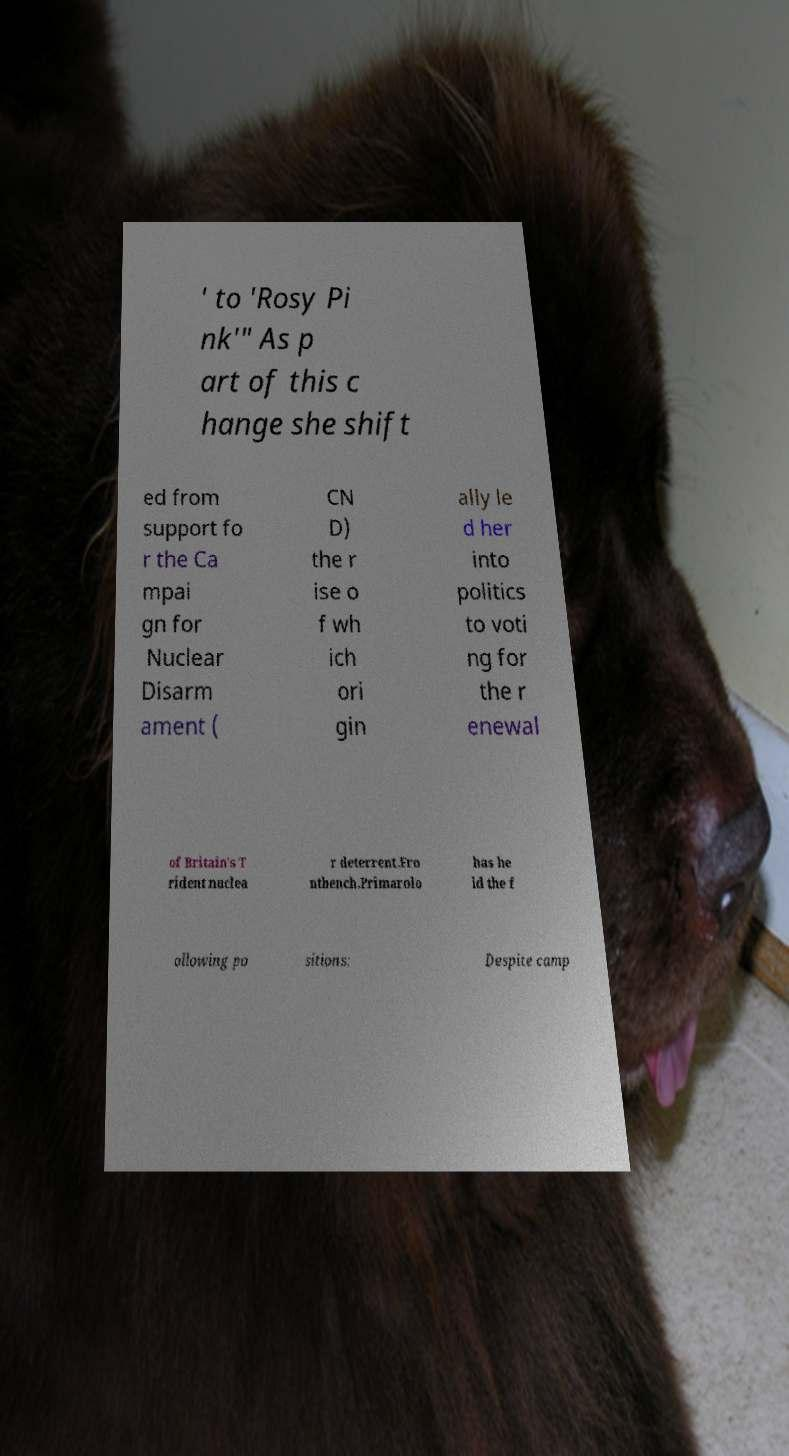Can you accurately transcribe the text from the provided image for me? ' to 'Rosy Pi nk'" As p art of this c hange she shift ed from support fo r the Ca mpai gn for Nuclear Disarm ament ( CN D) the r ise o f wh ich ori gin ally le d her into politics to voti ng for the r enewal of Britain's T rident nuclea r deterrent.Fro ntbench.Primarolo has he ld the f ollowing po sitions: Despite camp 